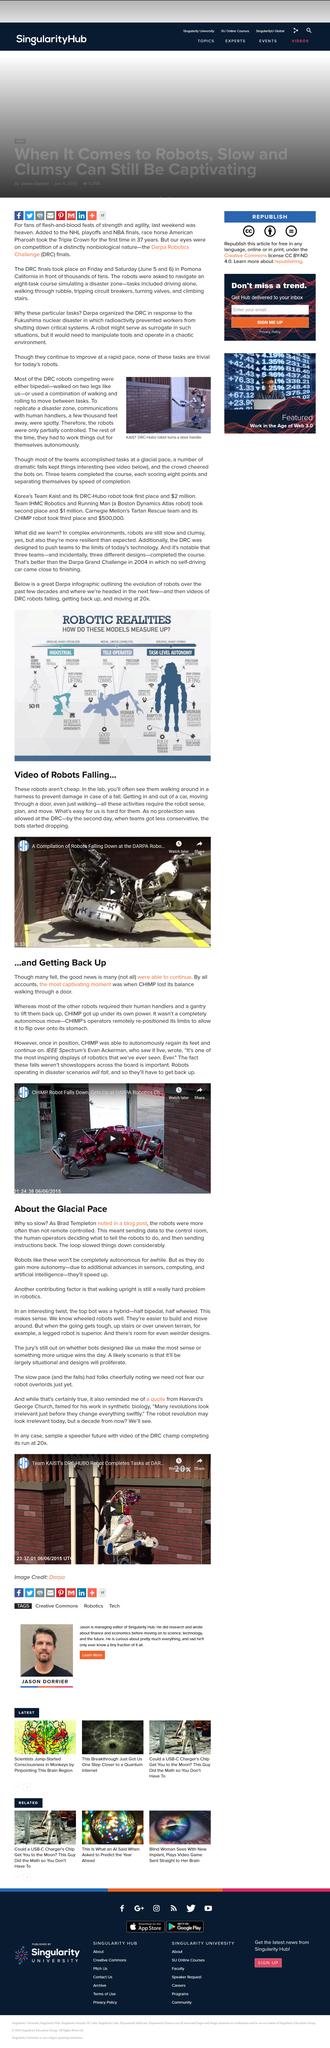Mention a couple of crucial points in this snapshot. Robots are typically remotely controlled, and this is the norm rather than the exception. Yes, robots are often perceived as slow and clumsy in complex environments, but they are actually more resilient than expected. On the second day, the teams became less cautious, and the robots began to malfunction. Out of the teams that finished the course, the total number of points scored by each team is eight (8). Robots are often considered to be slow and clumsy in complex environments, but they are actually more resilient than expected. 